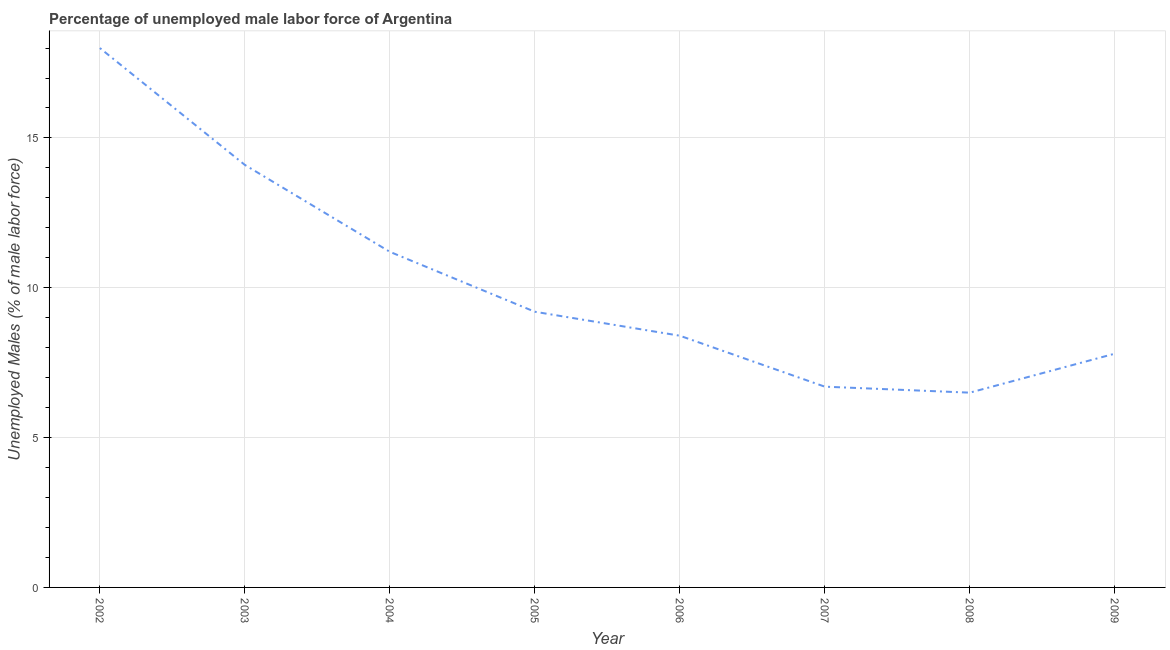Across all years, what is the maximum total unemployed male labour force?
Give a very brief answer. 18. Across all years, what is the minimum total unemployed male labour force?
Your answer should be very brief. 6.5. In which year was the total unemployed male labour force maximum?
Provide a short and direct response. 2002. What is the sum of the total unemployed male labour force?
Your answer should be very brief. 81.9. What is the difference between the total unemployed male labour force in 2006 and 2009?
Your answer should be compact. 0.6. What is the average total unemployed male labour force per year?
Make the answer very short. 10.24. What is the median total unemployed male labour force?
Ensure brevity in your answer.  8.8. In how many years, is the total unemployed male labour force greater than 17 %?
Provide a short and direct response. 1. Do a majority of the years between 2009 and 2004 (inclusive) have total unemployed male labour force greater than 15 %?
Give a very brief answer. Yes. What is the ratio of the total unemployed male labour force in 2002 to that in 2004?
Keep it short and to the point. 1.61. Is the difference between the total unemployed male labour force in 2003 and 2005 greater than the difference between any two years?
Your response must be concise. No. What is the difference between the highest and the second highest total unemployed male labour force?
Provide a succinct answer. 3.9. Is the sum of the total unemployed male labour force in 2002 and 2006 greater than the maximum total unemployed male labour force across all years?
Offer a very short reply. Yes. Does the total unemployed male labour force monotonically increase over the years?
Your response must be concise. No. How many lines are there?
Make the answer very short. 1. Are the values on the major ticks of Y-axis written in scientific E-notation?
Keep it short and to the point. No. What is the title of the graph?
Offer a very short reply. Percentage of unemployed male labor force of Argentina. What is the label or title of the X-axis?
Your response must be concise. Year. What is the label or title of the Y-axis?
Your response must be concise. Unemployed Males (% of male labor force). What is the Unemployed Males (% of male labor force) in 2003?
Your answer should be very brief. 14.1. What is the Unemployed Males (% of male labor force) in 2004?
Provide a succinct answer. 11.2. What is the Unemployed Males (% of male labor force) in 2005?
Your answer should be very brief. 9.2. What is the Unemployed Males (% of male labor force) of 2006?
Offer a very short reply. 8.4. What is the Unemployed Males (% of male labor force) of 2007?
Your response must be concise. 6.7. What is the Unemployed Males (% of male labor force) of 2008?
Provide a short and direct response. 6.5. What is the Unemployed Males (% of male labor force) of 2009?
Ensure brevity in your answer.  7.8. What is the difference between the Unemployed Males (% of male labor force) in 2002 and 2004?
Provide a short and direct response. 6.8. What is the difference between the Unemployed Males (% of male labor force) in 2002 and 2005?
Offer a very short reply. 8.8. What is the difference between the Unemployed Males (% of male labor force) in 2002 and 2006?
Offer a very short reply. 9.6. What is the difference between the Unemployed Males (% of male labor force) in 2002 and 2007?
Your answer should be compact. 11.3. What is the difference between the Unemployed Males (% of male labor force) in 2002 and 2009?
Make the answer very short. 10.2. What is the difference between the Unemployed Males (% of male labor force) in 2003 and 2004?
Your answer should be very brief. 2.9. What is the difference between the Unemployed Males (% of male labor force) in 2003 and 2006?
Provide a succinct answer. 5.7. What is the difference between the Unemployed Males (% of male labor force) in 2003 and 2007?
Ensure brevity in your answer.  7.4. What is the difference between the Unemployed Males (% of male labor force) in 2003 and 2009?
Offer a very short reply. 6.3. What is the difference between the Unemployed Males (% of male labor force) in 2004 and 2005?
Keep it short and to the point. 2. What is the difference between the Unemployed Males (% of male labor force) in 2004 and 2006?
Provide a short and direct response. 2.8. What is the difference between the Unemployed Males (% of male labor force) in 2004 and 2009?
Offer a terse response. 3.4. What is the difference between the Unemployed Males (% of male labor force) in 2005 and 2006?
Provide a short and direct response. 0.8. What is the difference between the Unemployed Males (% of male labor force) in 2005 and 2007?
Give a very brief answer. 2.5. What is the difference between the Unemployed Males (% of male labor force) in 2005 and 2009?
Give a very brief answer. 1.4. What is the difference between the Unemployed Males (% of male labor force) in 2006 and 2008?
Ensure brevity in your answer.  1.9. What is the difference between the Unemployed Males (% of male labor force) in 2007 and 2009?
Offer a very short reply. -1.1. What is the difference between the Unemployed Males (% of male labor force) in 2008 and 2009?
Your response must be concise. -1.3. What is the ratio of the Unemployed Males (% of male labor force) in 2002 to that in 2003?
Ensure brevity in your answer.  1.28. What is the ratio of the Unemployed Males (% of male labor force) in 2002 to that in 2004?
Give a very brief answer. 1.61. What is the ratio of the Unemployed Males (% of male labor force) in 2002 to that in 2005?
Make the answer very short. 1.96. What is the ratio of the Unemployed Males (% of male labor force) in 2002 to that in 2006?
Give a very brief answer. 2.14. What is the ratio of the Unemployed Males (% of male labor force) in 2002 to that in 2007?
Provide a short and direct response. 2.69. What is the ratio of the Unemployed Males (% of male labor force) in 2002 to that in 2008?
Ensure brevity in your answer.  2.77. What is the ratio of the Unemployed Males (% of male labor force) in 2002 to that in 2009?
Make the answer very short. 2.31. What is the ratio of the Unemployed Males (% of male labor force) in 2003 to that in 2004?
Offer a terse response. 1.26. What is the ratio of the Unemployed Males (% of male labor force) in 2003 to that in 2005?
Your answer should be very brief. 1.53. What is the ratio of the Unemployed Males (% of male labor force) in 2003 to that in 2006?
Your answer should be very brief. 1.68. What is the ratio of the Unemployed Males (% of male labor force) in 2003 to that in 2007?
Ensure brevity in your answer.  2.1. What is the ratio of the Unemployed Males (% of male labor force) in 2003 to that in 2008?
Give a very brief answer. 2.17. What is the ratio of the Unemployed Males (% of male labor force) in 2003 to that in 2009?
Ensure brevity in your answer.  1.81. What is the ratio of the Unemployed Males (% of male labor force) in 2004 to that in 2005?
Provide a short and direct response. 1.22. What is the ratio of the Unemployed Males (% of male labor force) in 2004 to that in 2006?
Your answer should be compact. 1.33. What is the ratio of the Unemployed Males (% of male labor force) in 2004 to that in 2007?
Your answer should be very brief. 1.67. What is the ratio of the Unemployed Males (% of male labor force) in 2004 to that in 2008?
Your answer should be very brief. 1.72. What is the ratio of the Unemployed Males (% of male labor force) in 2004 to that in 2009?
Provide a short and direct response. 1.44. What is the ratio of the Unemployed Males (% of male labor force) in 2005 to that in 2006?
Keep it short and to the point. 1.09. What is the ratio of the Unemployed Males (% of male labor force) in 2005 to that in 2007?
Ensure brevity in your answer.  1.37. What is the ratio of the Unemployed Males (% of male labor force) in 2005 to that in 2008?
Provide a succinct answer. 1.42. What is the ratio of the Unemployed Males (% of male labor force) in 2005 to that in 2009?
Your answer should be compact. 1.18. What is the ratio of the Unemployed Males (% of male labor force) in 2006 to that in 2007?
Provide a succinct answer. 1.25. What is the ratio of the Unemployed Males (% of male labor force) in 2006 to that in 2008?
Your answer should be compact. 1.29. What is the ratio of the Unemployed Males (% of male labor force) in 2006 to that in 2009?
Give a very brief answer. 1.08. What is the ratio of the Unemployed Males (% of male labor force) in 2007 to that in 2008?
Ensure brevity in your answer.  1.03. What is the ratio of the Unemployed Males (% of male labor force) in 2007 to that in 2009?
Offer a very short reply. 0.86. What is the ratio of the Unemployed Males (% of male labor force) in 2008 to that in 2009?
Your answer should be compact. 0.83. 